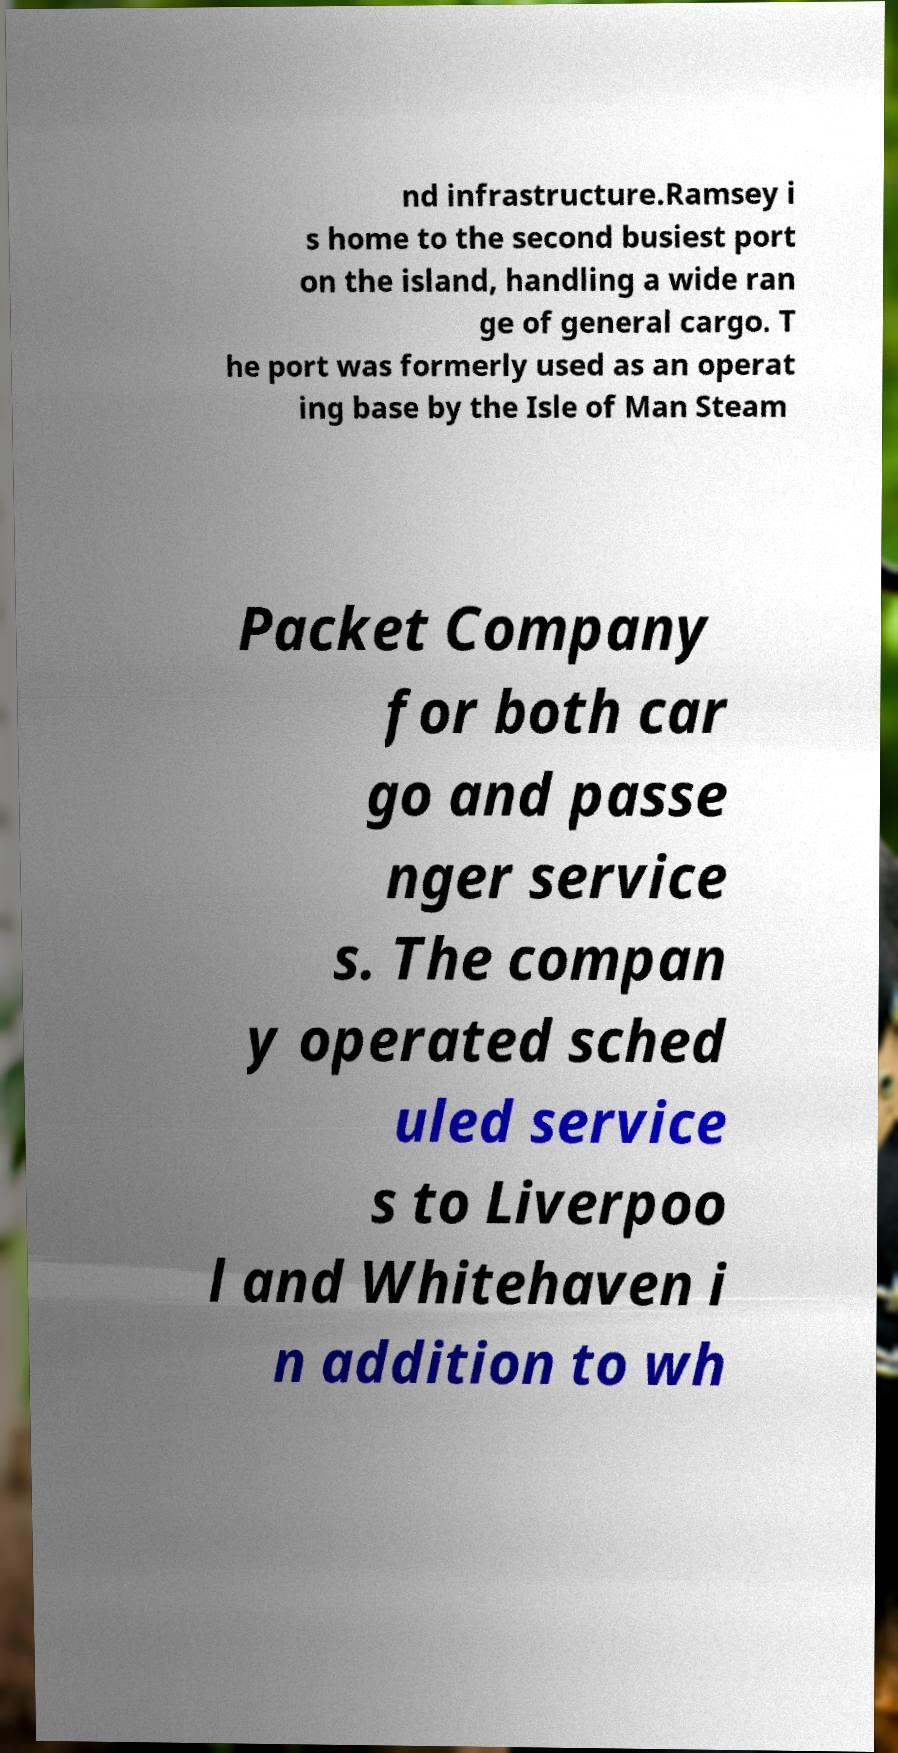Please read and relay the text visible in this image. What does it say? nd infrastructure.Ramsey i s home to the second busiest port on the island, handling a wide ran ge of general cargo. T he port was formerly used as an operat ing base by the Isle of Man Steam Packet Company for both car go and passe nger service s. The compan y operated sched uled service s to Liverpoo l and Whitehaven i n addition to wh 